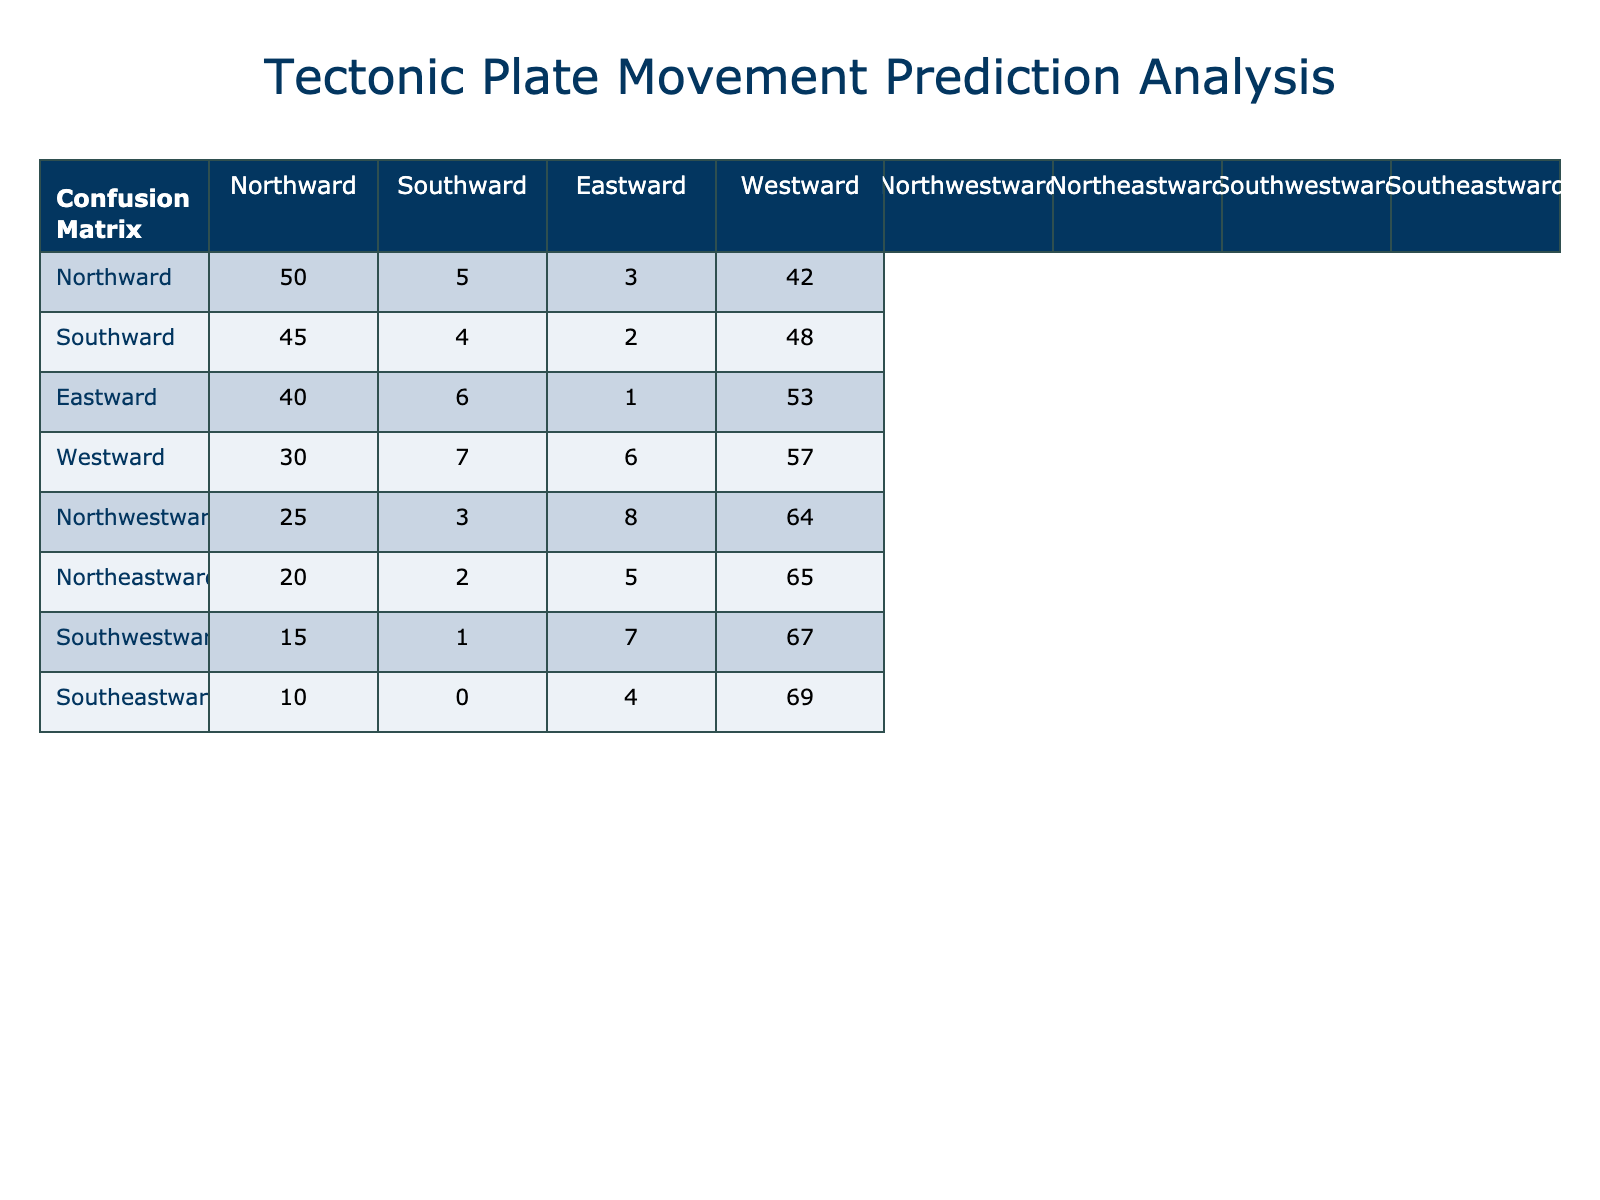What is the True Positive count for Southward movement predictions? The True Positive count for Southward predictions is 45, as indicated in the corresponding column under the Southward row.
Answer: 45 How many False Negatives are there for Northwestward movement predictions? The column for False Negatives shows that there are 8 False Negatives for Northwestward predictions.
Answer: 8 What is the total number of True Negatives across all movement predictions? To find the total True Negatives, we sum the values in the True Negative column: 42 + 48 + 53 + 57 + 64 + 65 + 67 + 69 = 432.
Answer: 432 Is there a higher number of False Positives for Eastward or Westward predictions? Eastward predictions have 6 False Positives, while Westward predictions have 7. Since 7 is greater than 6, Westward predictions have a higher number of False Positives.
Answer: Yes Which movement prediction has the lowest True Positive count? By reviewing the True Positive counts for all movements, we see that Southwestward has the lowest count with 15 True Positives.
Answer: Southwestward What is the difference between the True Positive counts of Northward and Northeastward predictions? The True Positive count for Northward is 50 and for Northeastward is 20. The difference is calculated as 50 - 20 = 30.
Answer: 30 When comparing Southward and Southeastward, which one has more True Negatives? Southward has 48 True Negatives, while Southeastward has 69. Since 69 is greater than 48, Southeastward has more True Negatives.
Answer: Southeastward What percentage of all predictions resulted in True Positives? The total True Positives are 50 + 45 + 40 + 30 + 25 + 20 + 15 + 10 = 235. The total number of predictions (sum of all categories) is 235 + 5 + 3 + 42 + 4 + 2 + 48 + 6 + 1 + 53 + 7 + 6 + 57 + 3 + 8 + 64 + 2 + 5 + 65 + 1 + 7 + 67 + 0 + 4 + 69 = 336. The percentage is (235 / 336) * 100 ≈ 69.94%.
Answer: 69.94% What is the sum of True Positives and True Negatives for all predictions? To find the sum, we calculate True Positives (235) and True Negatives (432), giving us 235 + 432 = 667.
Answer: 667 